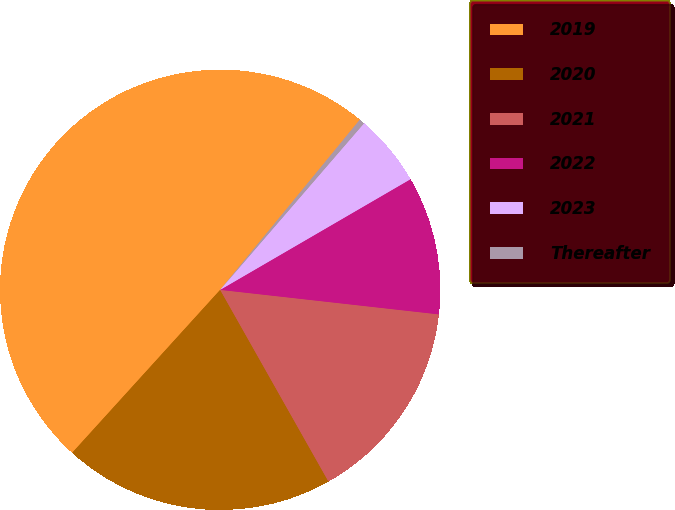Convert chart. <chart><loc_0><loc_0><loc_500><loc_500><pie_chart><fcel>2019<fcel>2020<fcel>2021<fcel>2022<fcel>2023<fcel>Thereafter<nl><fcel>49.21%<fcel>19.92%<fcel>15.04%<fcel>10.16%<fcel>5.28%<fcel>0.4%<nl></chart> 